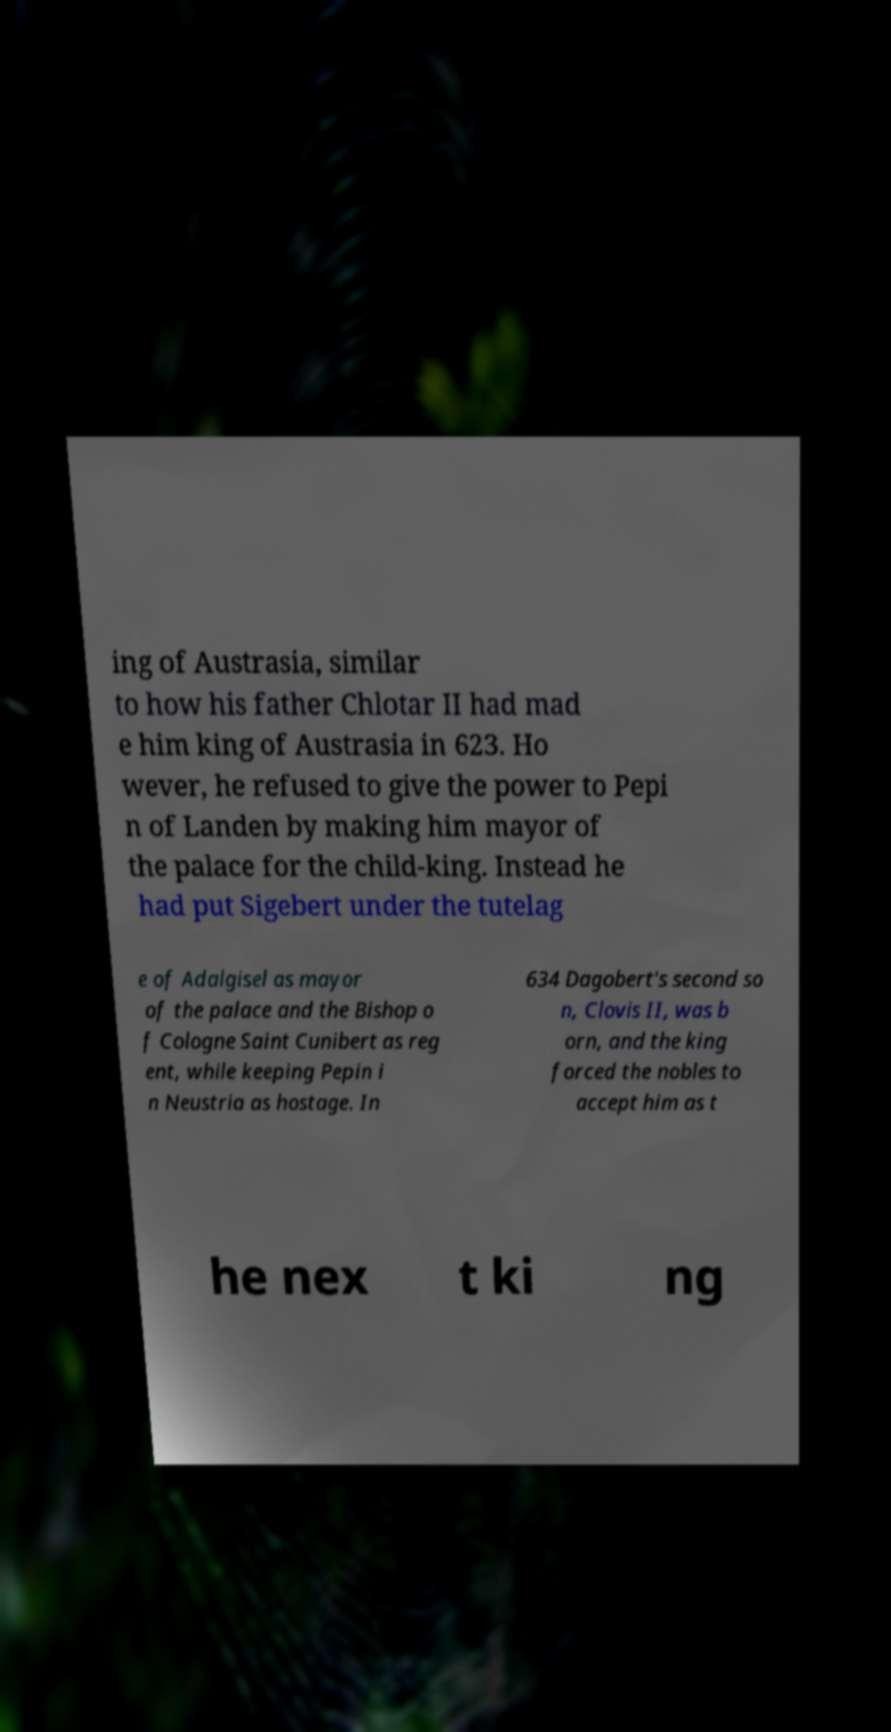Can you read and provide the text displayed in the image?This photo seems to have some interesting text. Can you extract and type it out for me? ing of Austrasia, similar to how his father Chlotar II had mad e him king of Austrasia in 623. Ho wever, he refused to give the power to Pepi n of Landen by making him mayor of the palace for the child-king. Instead he had put Sigebert under the tutelag e of Adalgisel as mayor of the palace and the Bishop o f Cologne Saint Cunibert as reg ent, while keeping Pepin i n Neustria as hostage. In 634 Dagobert's second so n, Clovis II, was b orn, and the king forced the nobles to accept him as t he nex t ki ng 